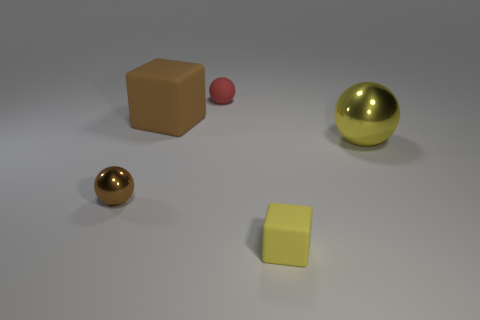Is the material of the red ball the same as the cube in front of the brown rubber cube?
Your response must be concise. Yes. Are there more large brown cubes in front of the brown metal object than yellow metal balls in front of the yellow block?
Ensure brevity in your answer.  No. What shape is the yellow shiny object?
Offer a very short reply. Sphere. Is the material of the thing that is behind the big matte object the same as the cube that is behind the tiny brown metallic sphere?
Your answer should be compact. Yes. What shape is the matte object that is in front of the large brown thing?
Your answer should be very brief. Cube. There is a yellow shiny thing that is the same shape as the tiny brown object; what size is it?
Provide a succinct answer. Large. Does the large metallic thing have the same color as the tiny cube?
Provide a short and direct response. Yes. Is there any other thing that is the same shape as the big brown thing?
Provide a succinct answer. Yes. There is a small red rubber ball behind the large matte thing; is there a tiny shiny sphere that is in front of it?
Offer a terse response. Yes. There is a tiny matte object that is the same shape as the small shiny object; what color is it?
Give a very brief answer. Red. 